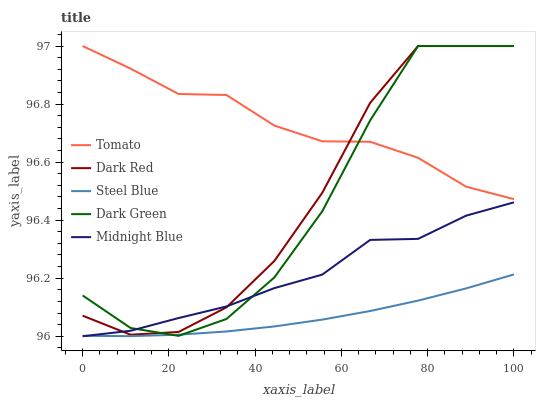Does Steel Blue have the minimum area under the curve?
Answer yes or no. Yes. Does Tomato have the maximum area under the curve?
Answer yes or no. Yes. Does Dark Red have the minimum area under the curve?
Answer yes or no. No. Does Dark Red have the maximum area under the curve?
Answer yes or no. No. Is Steel Blue the smoothest?
Answer yes or no. Yes. Is Dark Green the roughest?
Answer yes or no. Yes. Is Dark Red the smoothest?
Answer yes or no. No. Is Dark Red the roughest?
Answer yes or no. No. Does Midnight Blue have the lowest value?
Answer yes or no. Yes. Does Dark Red have the lowest value?
Answer yes or no. No. Does Dark Green have the highest value?
Answer yes or no. Yes. Does Midnight Blue have the highest value?
Answer yes or no. No. Is Midnight Blue less than Tomato?
Answer yes or no. Yes. Is Tomato greater than Steel Blue?
Answer yes or no. Yes. Does Steel Blue intersect Midnight Blue?
Answer yes or no. Yes. Is Steel Blue less than Midnight Blue?
Answer yes or no. No. Is Steel Blue greater than Midnight Blue?
Answer yes or no. No. Does Midnight Blue intersect Tomato?
Answer yes or no. No. 